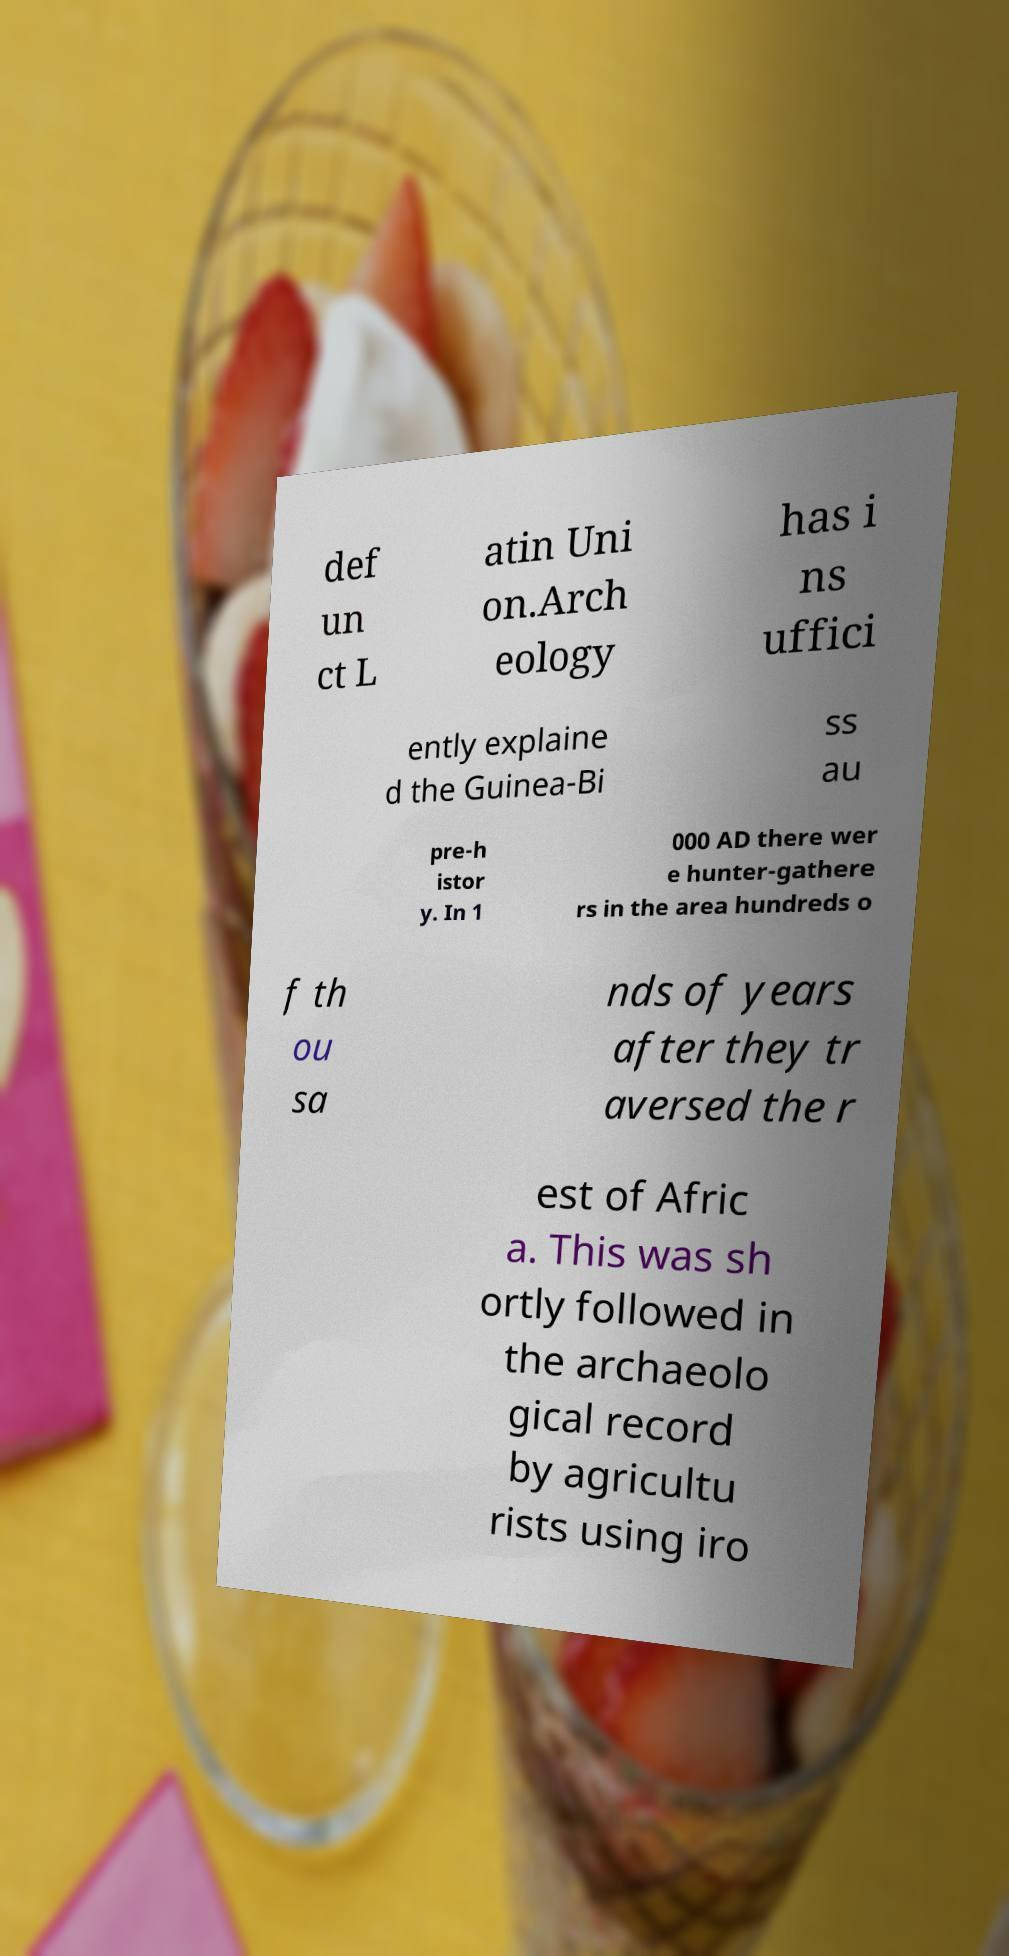There's text embedded in this image that I need extracted. Can you transcribe it verbatim? def un ct L atin Uni on.Arch eology has i ns uffici ently explaine d the Guinea-Bi ss au pre-h istor y. In 1 000 AD there wer e hunter-gathere rs in the area hundreds o f th ou sa nds of years after they tr aversed the r est of Afric a. This was sh ortly followed in the archaeolo gical record by agricultu rists using iro 